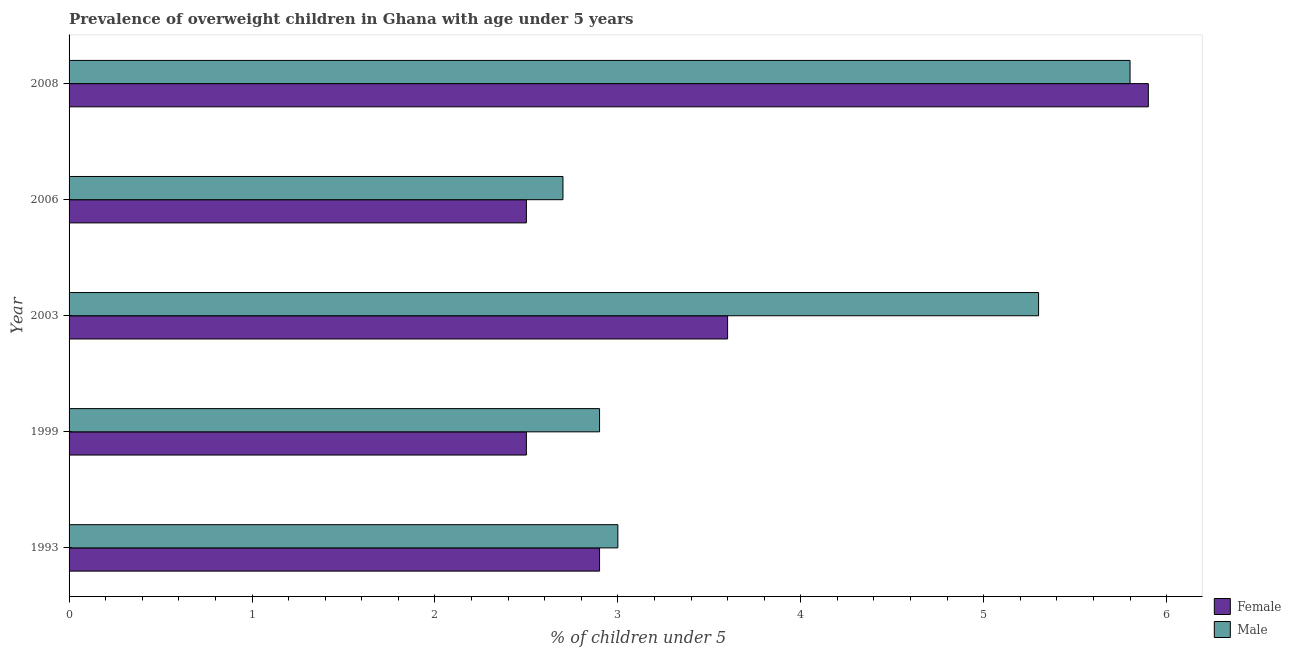How many different coloured bars are there?
Provide a short and direct response. 2. Are the number of bars on each tick of the Y-axis equal?
Your response must be concise. Yes. How many bars are there on the 4th tick from the bottom?
Keep it short and to the point. 2. What is the label of the 5th group of bars from the top?
Make the answer very short. 1993. What is the percentage of obese female children in 1999?
Your response must be concise. 2.5. Across all years, what is the maximum percentage of obese male children?
Offer a very short reply. 5.8. Across all years, what is the minimum percentage of obese female children?
Ensure brevity in your answer.  2.5. In which year was the percentage of obese female children maximum?
Your answer should be compact. 2008. In which year was the percentage of obese female children minimum?
Offer a terse response. 1999. What is the total percentage of obese female children in the graph?
Provide a short and direct response. 17.4. What is the difference between the percentage of obese female children in 1993 and that in 2008?
Offer a very short reply. -3. What is the difference between the percentage of obese male children in 2008 and the percentage of obese female children in 1999?
Your answer should be very brief. 3.3. What is the average percentage of obese male children per year?
Provide a short and direct response. 3.94. What is the ratio of the percentage of obese female children in 1993 to that in 2008?
Your answer should be very brief. 0.49. Is the percentage of obese male children in 1993 less than that in 2006?
Your answer should be compact. No. What is the difference between the highest and the lowest percentage of obese male children?
Provide a succinct answer. 3.1. In how many years, is the percentage of obese female children greater than the average percentage of obese female children taken over all years?
Give a very brief answer. 2. Is the sum of the percentage of obese male children in 2006 and 2008 greater than the maximum percentage of obese female children across all years?
Offer a terse response. Yes. What does the 1st bar from the top in 2008 represents?
Offer a terse response. Male. How many bars are there?
Offer a very short reply. 10. How many years are there in the graph?
Your answer should be very brief. 5. Are the values on the major ticks of X-axis written in scientific E-notation?
Your answer should be compact. No. Does the graph contain any zero values?
Keep it short and to the point. No. Where does the legend appear in the graph?
Offer a very short reply. Bottom right. What is the title of the graph?
Your response must be concise. Prevalence of overweight children in Ghana with age under 5 years. What is the label or title of the X-axis?
Ensure brevity in your answer.   % of children under 5. What is the  % of children under 5 of Female in 1993?
Ensure brevity in your answer.  2.9. What is the  % of children under 5 in Male in 1993?
Keep it short and to the point. 3. What is the  % of children under 5 in Male in 1999?
Offer a terse response. 2.9. What is the  % of children under 5 in Female in 2003?
Ensure brevity in your answer.  3.6. What is the  % of children under 5 of Male in 2003?
Provide a short and direct response. 5.3. What is the  % of children under 5 of Male in 2006?
Give a very brief answer. 2.7. What is the  % of children under 5 of Female in 2008?
Provide a succinct answer. 5.9. What is the  % of children under 5 of Male in 2008?
Ensure brevity in your answer.  5.8. Across all years, what is the maximum  % of children under 5 of Female?
Make the answer very short. 5.9. Across all years, what is the maximum  % of children under 5 in Male?
Your answer should be very brief. 5.8. Across all years, what is the minimum  % of children under 5 in Male?
Provide a succinct answer. 2.7. What is the total  % of children under 5 in Female in the graph?
Offer a terse response. 17.4. What is the difference between the  % of children under 5 of Female in 1993 and that in 2003?
Make the answer very short. -0.7. What is the difference between the  % of children under 5 of Male in 1993 and that in 2008?
Your answer should be very brief. -2.8. What is the difference between the  % of children under 5 in Female in 1999 and that in 2003?
Your answer should be very brief. -1.1. What is the difference between the  % of children under 5 in Male in 1999 and that in 2006?
Your answer should be very brief. 0.2. What is the difference between the  % of children under 5 of Female in 2003 and that in 2006?
Offer a terse response. 1.1. What is the difference between the  % of children under 5 in Male in 2003 and that in 2006?
Provide a short and direct response. 2.6. What is the difference between the  % of children under 5 of Male in 2003 and that in 2008?
Your answer should be very brief. -0.5. What is the difference between the  % of children under 5 in Male in 2006 and that in 2008?
Provide a succinct answer. -3.1. What is the difference between the  % of children under 5 of Female in 1993 and the  % of children under 5 of Male in 2008?
Offer a very short reply. -2.9. What is the difference between the  % of children under 5 in Female in 1999 and the  % of children under 5 in Male in 2006?
Keep it short and to the point. -0.2. What is the difference between the  % of children under 5 in Female in 1999 and the  % of children under 5 in Male in 2008?
Provide a succinct answer. -3.3. What is the difference between the  % of children under 5 in Female in 2003 and the  % of children under 5 in Male in 2008?
Provide a succinct answer. -2.2. What is the average  % of children under 5 of Female per year?
Your response must be concise. 3.48. What is the average  % of children under 5 in Male per year?
Provide a short and direct response. 3.94. In the year 2003, what is the difference between the  % of children under 5 of Female and  % of children under 5 of Male?
Offer a terse response. -1.7. In the year 2006, what is the difference between the  % of children under 5 of Female and  % of children under 5 of Male?
Offer a terse response. -0.2. What is the ratio of the  % of children under 5 of Female in 1993 to that in 1999?
Keep it short and to the point. 1.16. What is the ratio of the  % of children under 5 in Male in 1993 to that in 1999?
Provide a succinct answer. 1.03. What is the ratio of the  % of children under 5 in Female in 1993 to that in 2003?
Provide a succinct answer. 0.81. What is the ratio of the  % of children under 5 in Male in 1993 to that in 2003?
Offer a terse response. 0.57. What is the ratio of the  % of children under 5 in Female in 1993 to that in 2006?
Your answer should be compact. 1.16. What is the ratio of the  % of children under 5 of Female in 1993 to that in 2008?
Provide a succinct answer. 0.49. What is the ratio of the  % of children under 5 of Male in 1993 to that in 2008?
Give a very brief answer. 0.52. What is the ratio of the  % of children under 5 in Female in 1999 to that in 2003?
Your response must be concise. 0.69. What is the ratio of the  % of children under 5 in Male in 1999 to that in 2003?
Keep it short and to the point. 0.55. What is the ratio of the  % of children under 5 of Female in 1999 to that in 2006?
Your answer should be very brief. 1. What is the ratio of the  % of children under 5 of Male in 1999 to that in 2006?
Give a very brief answer. 1.07. What is the ratio of the  % of children under 5 of Female in 1999 to that in 2008?
Give a very brief answer. 0.42. What is the ratio of the  % of children under 5 of Male in 1999 to that in 2008?
Offer a very short reply. 0.5. What is the ratio of the  % of children under 5 of Female in 2003 to that in 2006?
Make the answer very short. 1.44. What is the ratio of the  % of children under 5 of Male in 2003 to that in 2006?
Ensure brevity in your answer.  1.96. What is the ratio of the  % of children under 5 in Female in 2003 to that in 2008?
Your answer should be very brief. 0.61. What is the ratio of the  % of children under 5 in Male in 2003 to that in 2008?
Give a very brief answer. 0.91. What is the ratio of the  % of children under 5 of Female in 2006 to that in 2008?
Give a very brief answer. 0.42. What is the ratio of the  % of children under 5 in Male in 2006 to that in 2008?
Your answer should be very brief. 0.47. What is the difference between the highest and the second highest  % of children under 5 in Female?
Ensure brevity in your answer.  2.3. What is the difference between the highest and the second highest  % of children under 5 in Male?
Keep it short and to the point. 0.5. 